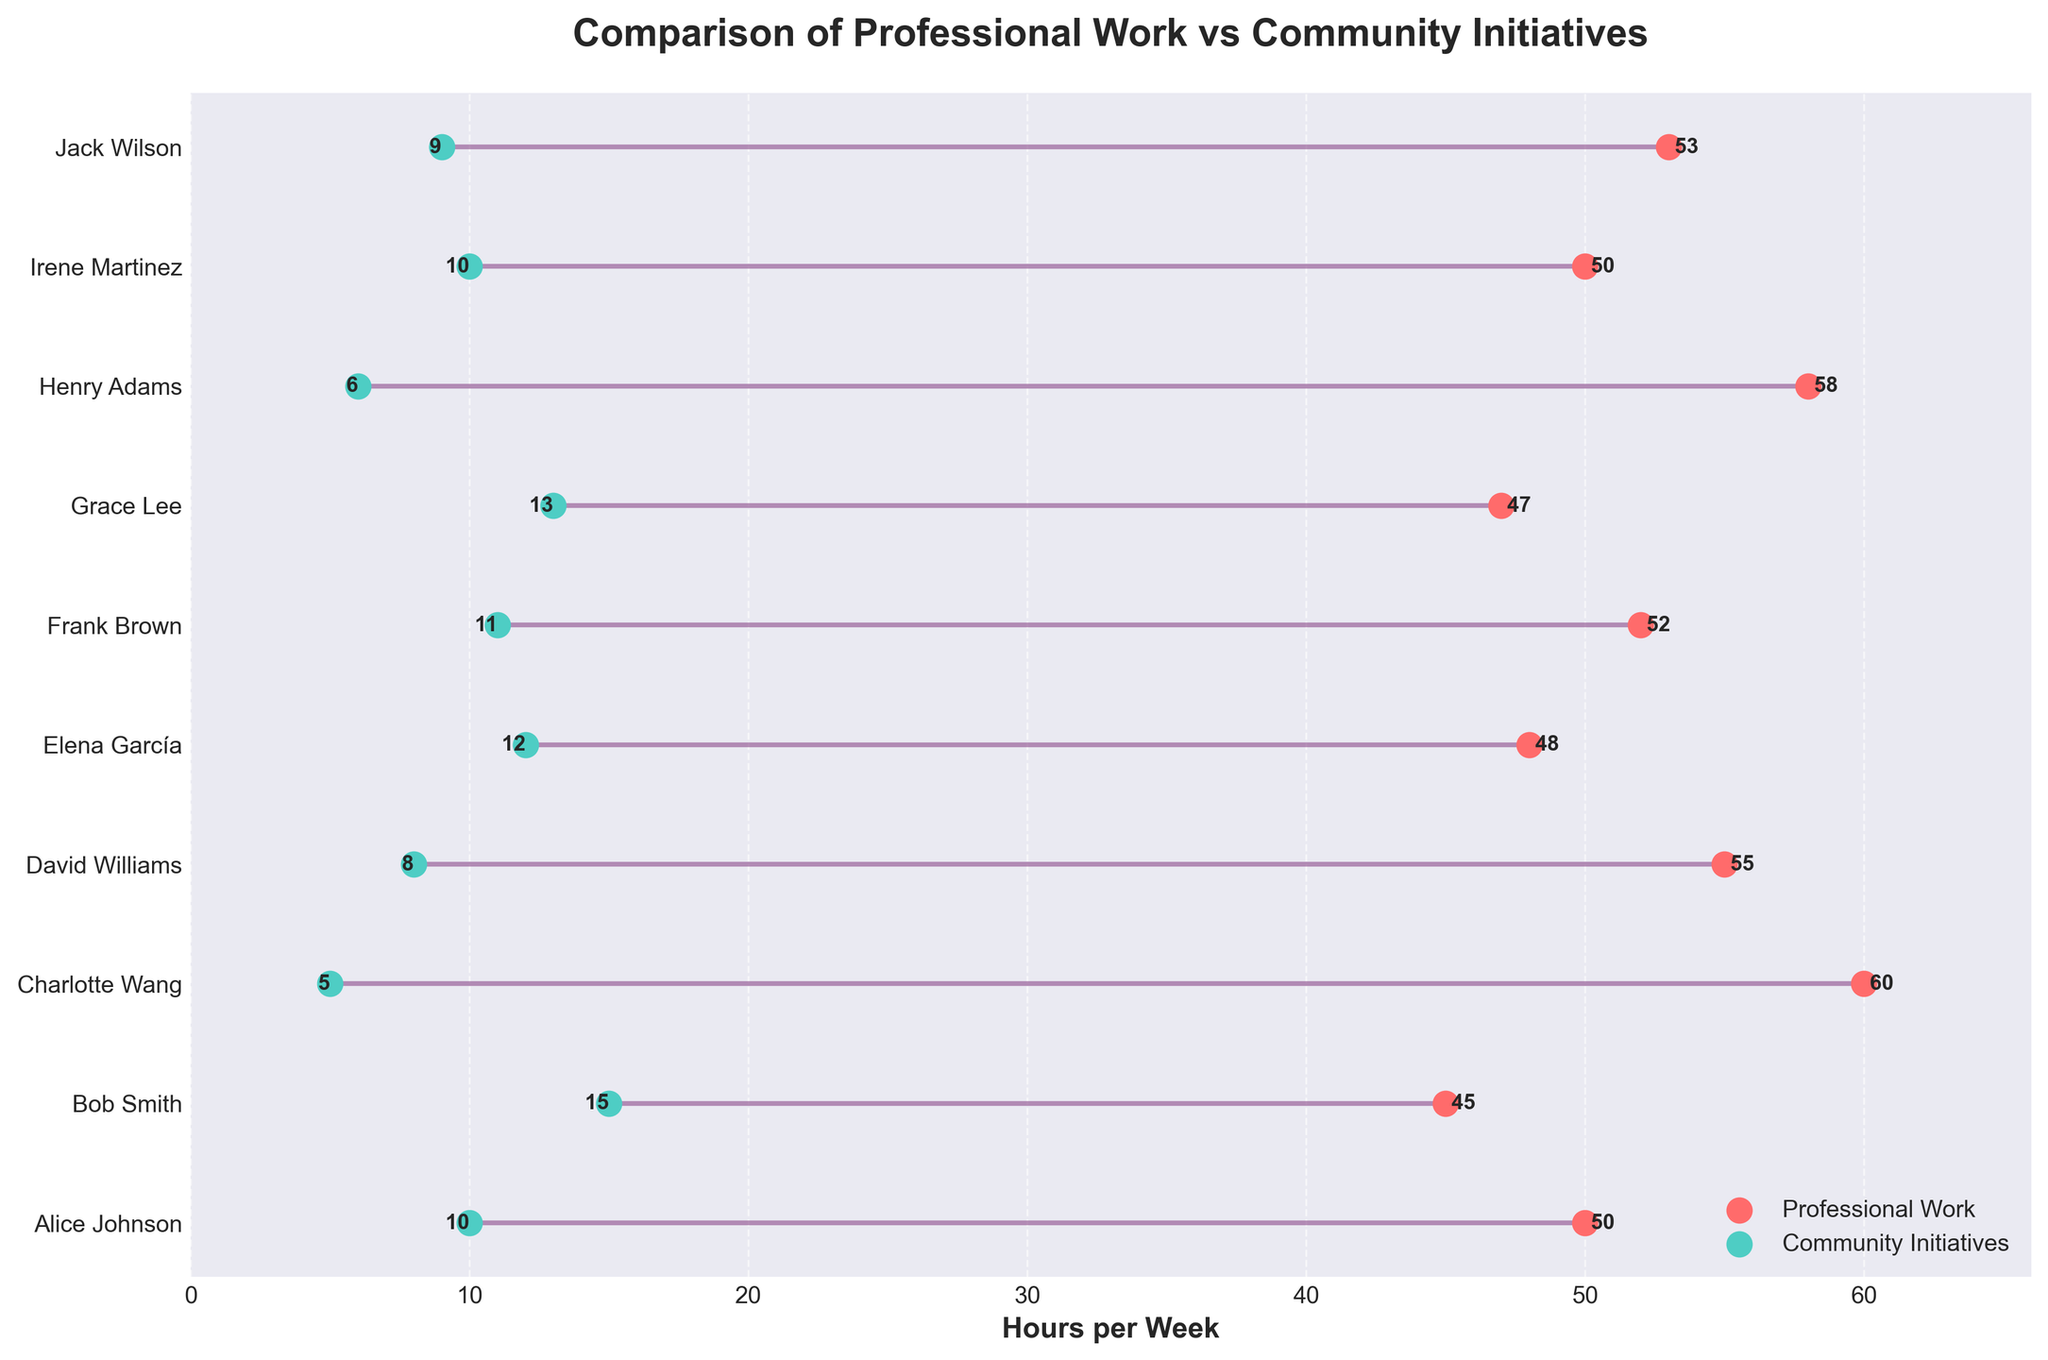What's the title of the plot? The title of the plot is displayed at the top of the figure, and it reads "Comparison of Professional Work vs Community Initiatives".
Answer: Comparison of Professional Work vs Community Initiatives How many business owners are compared in the figure? By counting the number of entries on the y-axis, which corresponds to the business owners, we see there are 10 business owners listed.
Answer: 10 What are the colors used for the professional work and community initiatives data points? The professional work data points are shown in red, and the community initiatives data points are shown in turquoise.
Answer: Red and turquoise Who spends the highest number of hours on professional work per week? By looking at the red points and their labels, the highest value is 60 hours per week, which corresponds to Charlotte Wang.
Answer: Charlotte Wang Who has the smallest difference between professional work hours and community initiatives hours? We need to find the smallest difference between the red and turquoise points for each owner. Alice Johnson and Irene Martinez each have a difference of 40 - 10 = 40 hours.
Answer: Alice Johnson and Irene Martinez What are the x-axis limits of the plot? By observing the x-axis, the limits range from 0 to slightly over 60. This indicates some padding was added to the maximum hours per week value.
Answer: 0 to slightly over 60 Which business owner spends the second highest number of hours on community initiatives? By looking at the turquoise points and their labels, the second highest value is 13 hours per week, which corresponds to Grace Lee.
Answer: Grace Lee How many business owners spend more than 50 hours per week on professional work? We have to count the red points that are placed beyond the 50 hours mark. The business owners are Alice Johnson, Charlotte Wang, David Williams, Henry Adams, and Jack Wilson.
Answer: 5 Who spends the most time overall, combining professional work and community initiatives? We calculate the sum of professional and community hours for each owner and find the highest total. Alice Johnson spends 50 + 10 = 60 hours, Bob Smith spends 45 + 15 = 60 hours, and so on. The highest sum is 60 + 5 = 65 hours for Charlotte Wang.
Answer: Charlotte Wang Is there any business owner who spends equal time on professional work and community initiatives? We compare the professional work hours to community initiatives hours for each owner and see that none of them have equal values.
Answer: No 